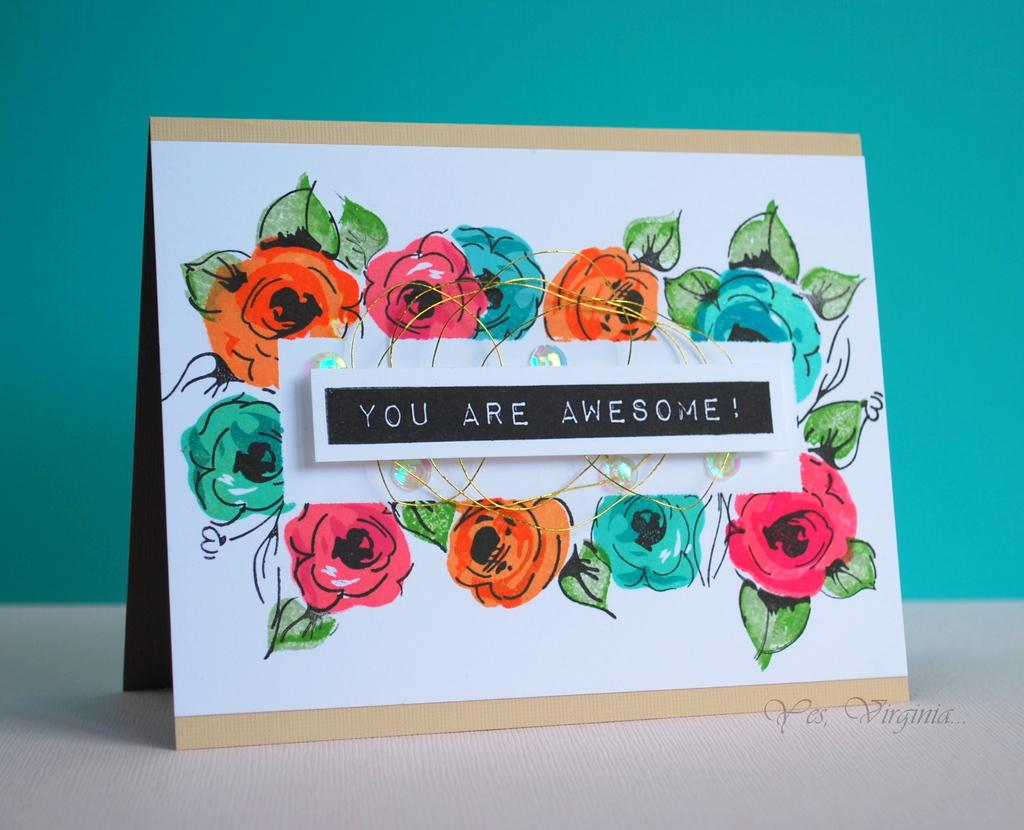What is the main object in the image? There is a greeting card in the image. What message does the greeting card contain? The greeting card has a welcome note. What design is featured on the greeting card? There is a drawing of flowers on the greeting card. Where is the greeting card located in the image? The greeting card is placed on a table. What can be seen in the background of the image? There is a blue wall in the background of the image. Is there a frame around the drawing of flowers on the greeting card? There is no mention of a frame in the provided facts, so we cannot determine if there is a frame around the drawing of flowers on the greeting card. How much debt is associated with the greeting card in the image? There is no mention of debt in the provided facts, so we cannot determine if there is any debt associated with the greeting card in the image. 